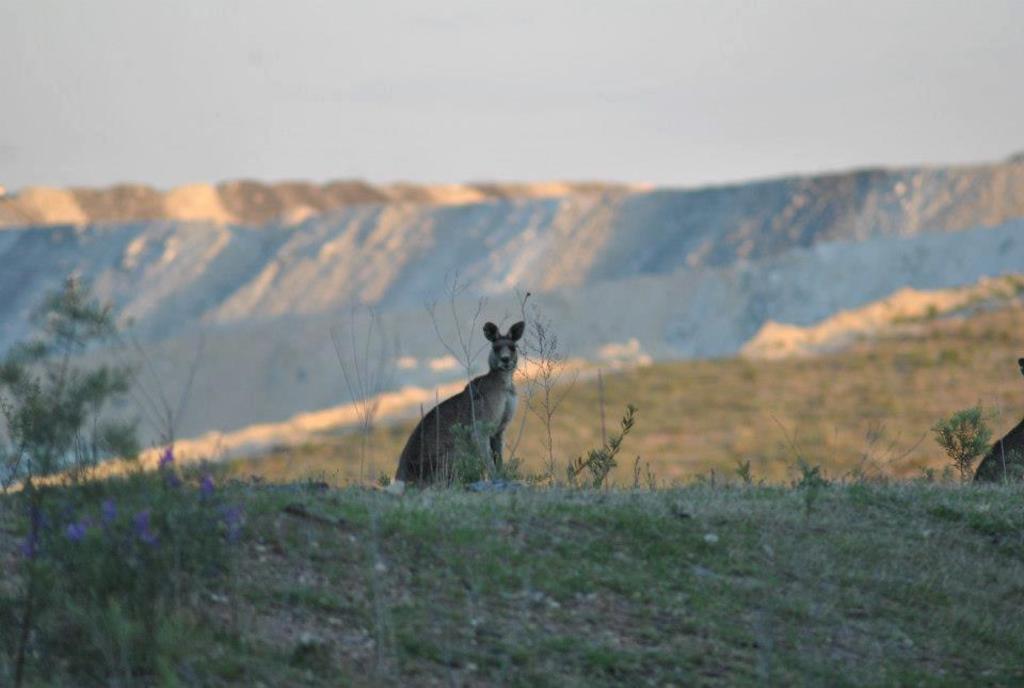How would you summarize this image in a sentence or two? In the center of the image an animal is there. In the background of the image mountains are there. At the bottom of the image we can see some plants grass, ground are present. At the top of the image sky is there. 